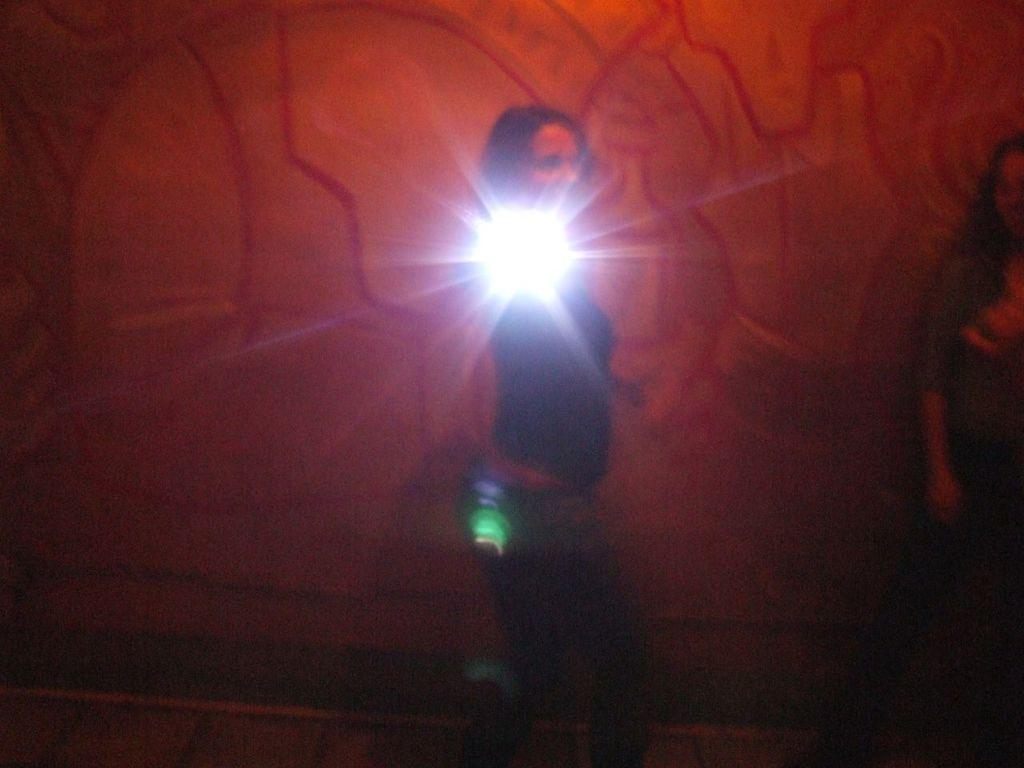Who or what is the main subject in the image? There is a person in the image. What else can be seen in the image besides the person? There are lights and another person on the right side of the image. What is the background of the image like? There is a colorful wall in the background of the image. Can you tell me how many bikes are parked near the edge of the image? There are no bikes present in the image. What type of request is being made by the person on the right side of the image? There is no indication of a request being made in the image. 